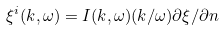<formula> <loc_0><loc_0><loc_500><loc_500>\xi ^ { i } ( k , \omega ) = I ( k , \omega ) ( k / \omega ) \partial \xi / \partial n</formula> 